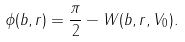<formula> <loc_0><loc_0><loc_500><loc_500>\phi ( b , r ) = \frac { \pi } { 2 } - W ( b , r , V _ { 0 } ) .</formula> 